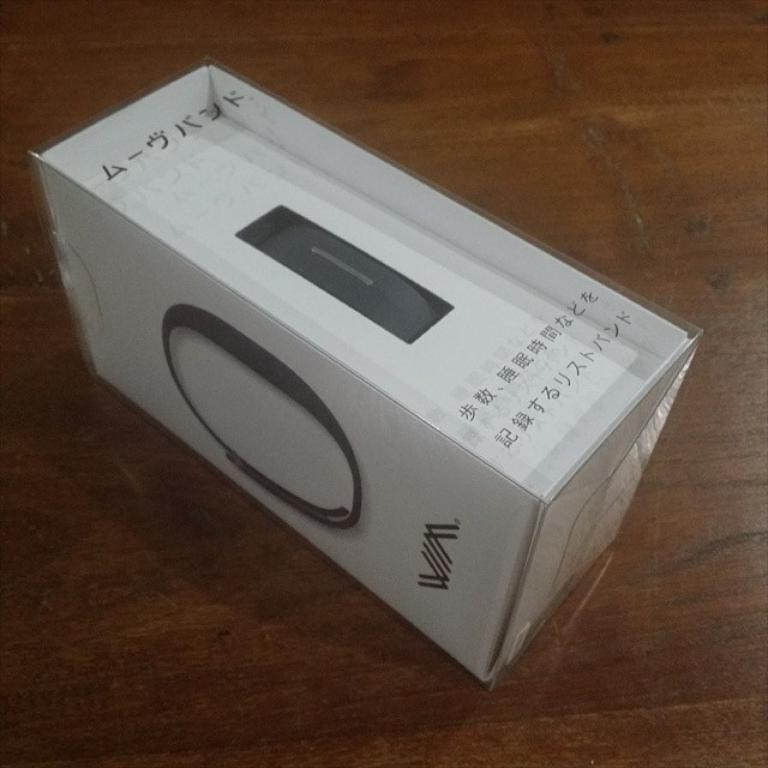What is the main object in the image? There is a white cardboard box in the image. What can be observed about the text on the box? The text on the box is written in a different language. Where is the box located in the image? The box is placed on a wooden table. What is the color of the wooden table? The wooden table is brown in color. How does the dock appear in the image? There is no dock present in the image; it only features a white cardboard box on a wooden table. 